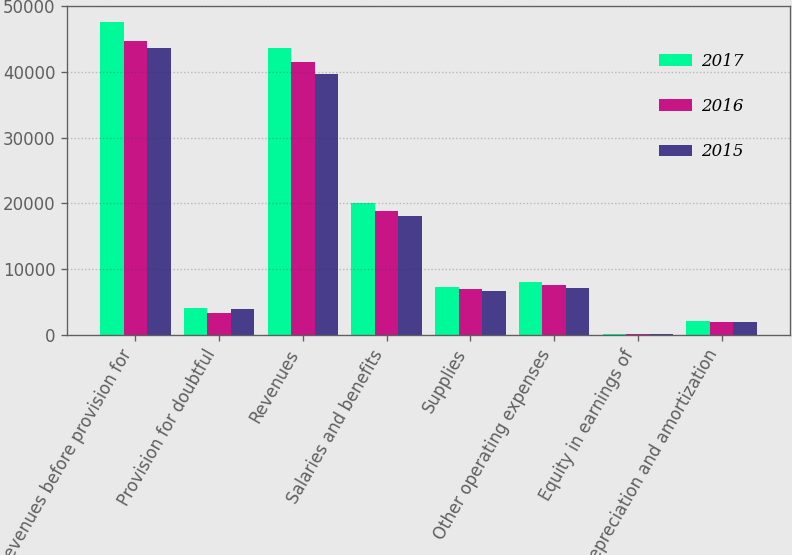Convert chart. <chart><loc_0><loc_0><loc_500><loc_500><stacked_bar_chart><ecel><fcel>Revenues before provision for<fcel>Provision for doubtful<fcel>Revenues<fcel>Salaries and benefits<fcel>Supplies<fcel>Other operating expenses<fcel>Equity in earnings of<fcel>Depreciation and amortization<nl><fcel>2017<fcel>47653<fcel>4039<fcel>43614<fcel>20059<fcel>7316<fcel>8051<fcel>45<fcel>2131<nl><fcel>2016<fcel>44747<fcel>3257<fcel>41490<fcel>18897<fcel>6933<fcel>7496<fcel>54<fcel>1966<nl><fcel>2015<fcel>43591<fcel>3913<fcel>39678<fcel>18115<fcel>6638<fcel>7056<fcel>46<fcel>1904<nl></chart> 